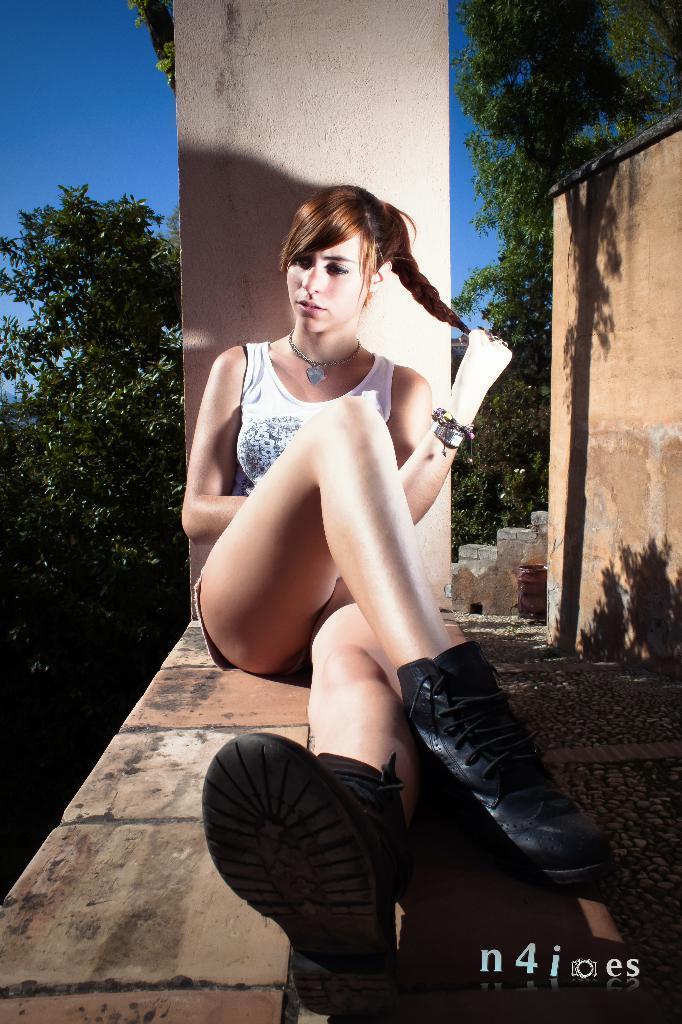Please provide a concise description of this image. In this image, we can see a girl sitting, at the right side there is a wall and there are some trees, at the top there is a blue color sky. 